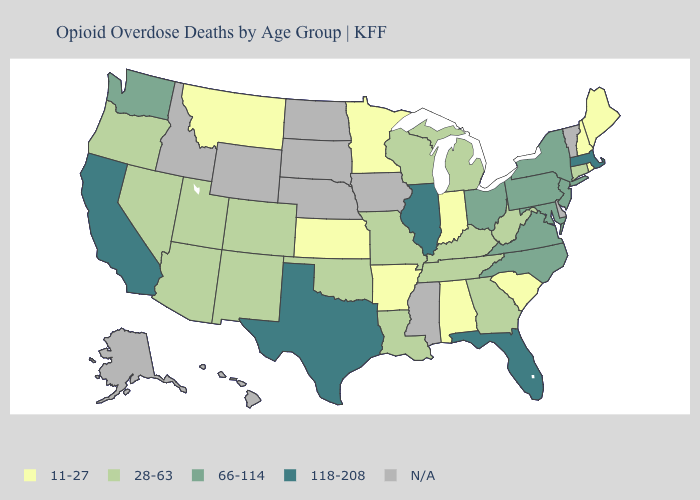Among the states that border North Carolina , does Virginia have the lowest value?
Short answer required. No. What is the value of Idaho?
Concise answer only. N/A. Among the states that border Virginia , which have the highest value?
Write a very short answer. Maryland, North Carolina. Does Illinois have the highest value in the USA?
Quick response, please. Yes. Which states have the lowest value in the USA?
Write a very short answer. Alabama, Arkansas, Indiana, Kansas, Maine, Minnesota, Montana, New Hampshire, Rhode Island, South Carolina. What is the value of Louisiana?
Quick response, please. 28-63. What is the lowest value in the MidWest?
Write a very short answer. 11-27. Among the states that border Utah , which have the highest value?
Be succinct. Arizona, Colorado, Nevada, New Mexico. What is the value of Massachusetts?
Give a very brief answer. 118-208. Name the states that have a value in the range 118-208?
Quick response, please. California, Florida, Illinois, Massachusetts, Texas. Does the map have missing data?
Quick response, please. Yes. What is the value of Ohio?
Be succinct. 66-114. How many symbols are there in the legend?
Answer briefly. 5. What is the value of Hawaii?
Concise answer only. N/A. How many symbols are there in the legend?
Quick response, please. 5. 